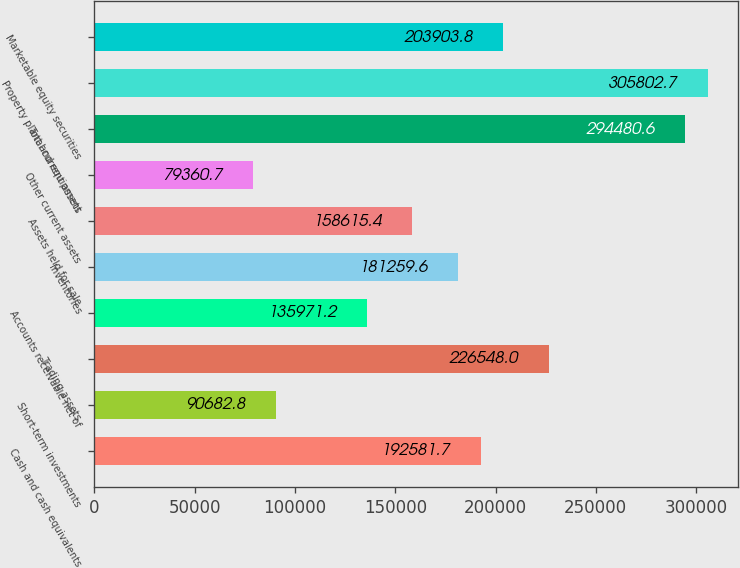Convert chart to OTSL. <chart><loc_0><loc_0><loc_500><loc_500><bar_chart><fcel>Cash and cash equivalents<fcel>Short-term investments<fcel>Trading assets<fcel>Accounts receivable net of<fcel>Inventories<fcel>Assets held for sale<fcel>Other current assets<fcel>Total current assets<fcel>Property plant and equipment<fcel>Marketable equity securities<nl><fcel>192582<fcel>90682.8<fcel>226548<fcel>135971<fcel>181260<fcel>158615<fcel>79360.7<fcel>294481<fcel>305803<fcel>203904<nl></chart> 